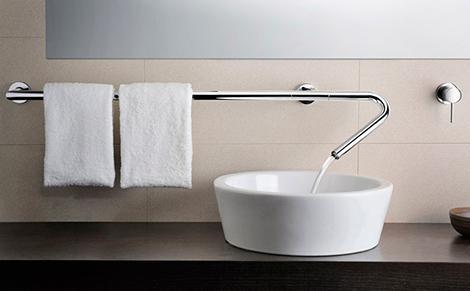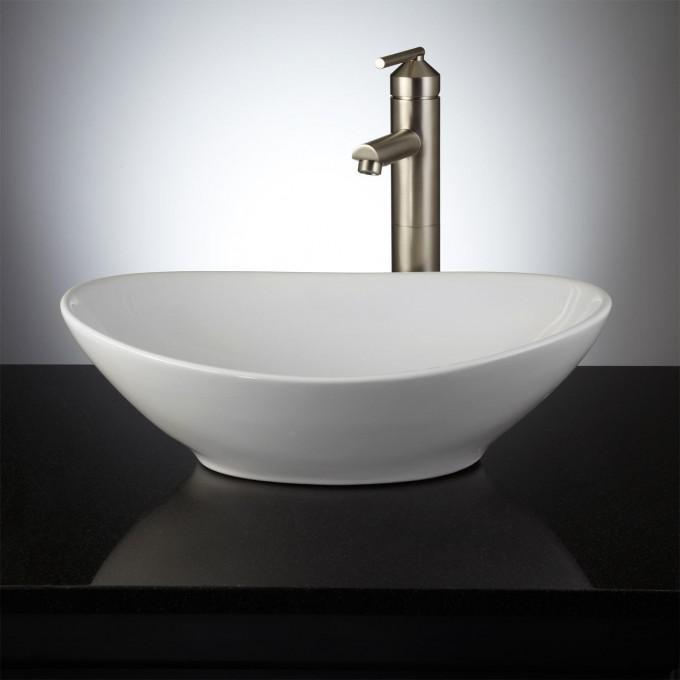The first image is the image on the left, the second image is the image on the right. Considering the images on both sides, is "A thin stream of water is flowing into a sink that sits atop a dark wood counter in one image." valid? Answer yes or no. Yes. The first image is the image on the left, the second image is the image on the right. Analyze the images presented: Is the assertion "A round mirror is above a sink." valid? Answer yes or no. No. 